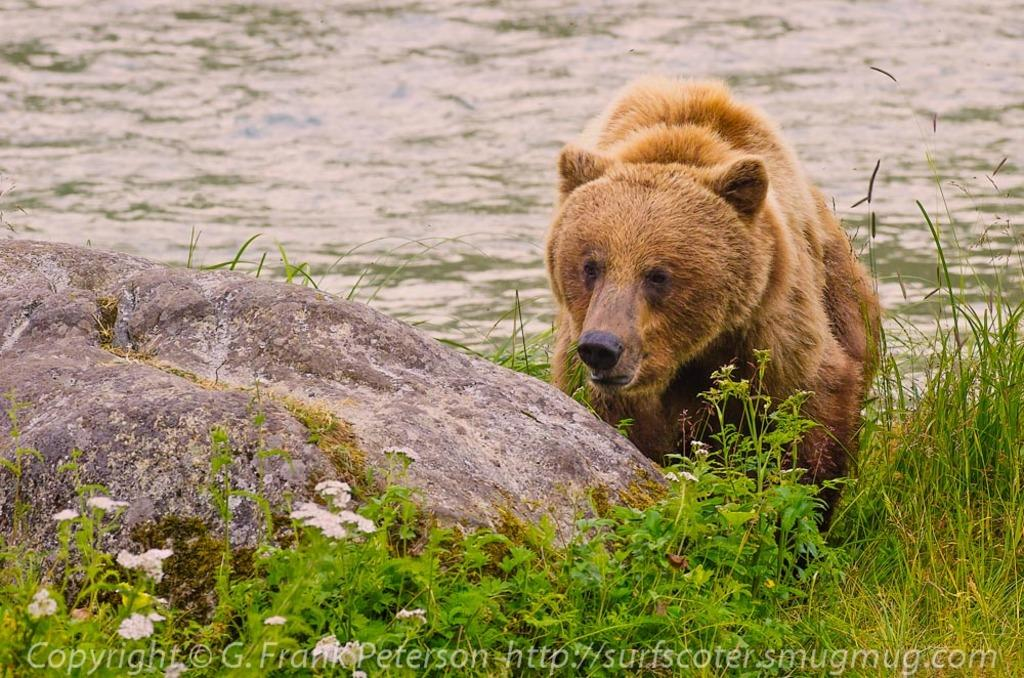What type of animal is in the image? There is a brown bear in the image. What color are the plants in the image? The plants in the image are green. What can be seen in the background of the image? There is water visible in the background of the image. What causes the bear to quiver in the image? There is no indication in the image that the bear is quivering, and no cause for it is mentioned or depicted. 